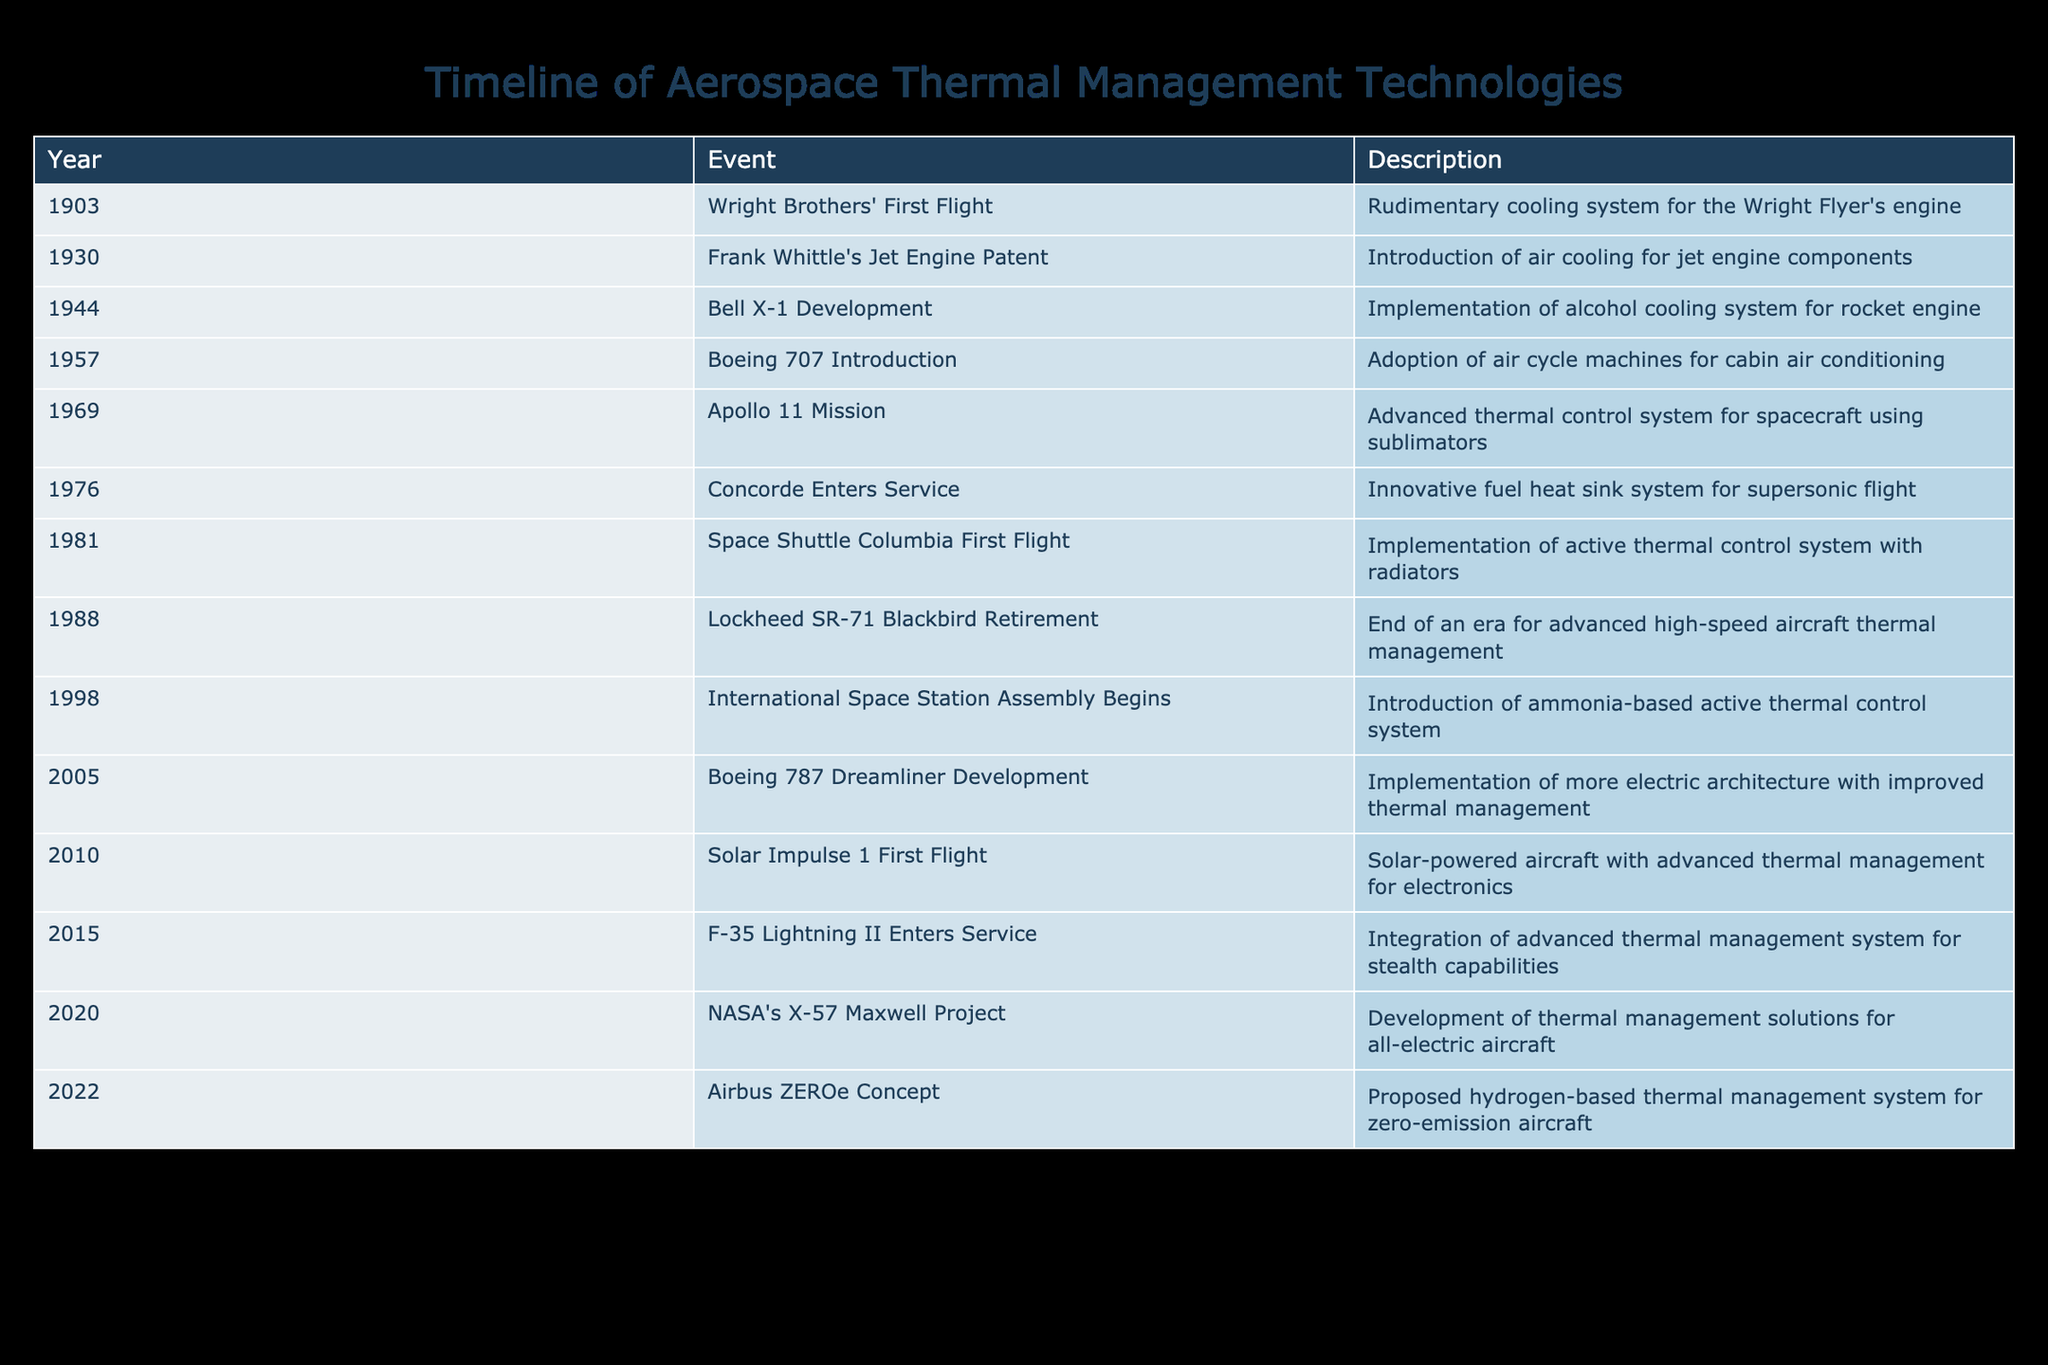What event marks the introduction of air cooling for jet engines? According to the table, the event that marks the introduction of air cooling for jet engines is Frank Whittle's Jet Engine Patent, which occurred in 1930.
Answer: Frank Whittle's Jet Engine Patent How many years passed between the Apollo 11 Mission and the Boeing 787 Dreamliner Development? The Apollo 11 Mission took place in 1969, and the Boeing 787 Dreamliner Development began in 2005. The difference in years is calculated as 2005 - 1969 = 36 years.
Answer: 36 years Is the Bell X-1 Development associated with a cooling system? Yes, the Bell X-1 Development in 1944 is noted for the implementation of an alcohol cooling system for rocket engines.
Answer: Yes What was the last event listed in the table? Reviewing the table, the last event listed is the Airbus ZEROe Concept, proposed in 2022, which discusses a hydrogen-based thermal management system for zero-emission aircraft.
Answer: Airbus ZEROe Concept What was the average number of years between the events listed from 1944 to 2010? The events from 1944 to 2010 in the table include Bell X-1 Development (1944), Space Shuttle Columbia First Flight (1981), and Solar Impulse 1 First Flight (2010). The years are 1944, 1981, and 2010. First, we calculate the intervals: 1981 - 1944 = 37 years, and 2010 - 1981 = 29 years. The total interval is 37 + 29 = 66 years, and there are 2 gaps, so the average is 66 / 2 = 33 years.
Answer: 33 years How many events between 2000 and 2022 involved advanced thermal management systems? Reviewing the table, the events between 2000 and 2022 are: International Space Station Assembly Begins (1998), Boeing 787 Dreamliner Development (2005), F-35 Lightning II Enters Service (2015), NASA's X-57 Maxwell Project (2020), and Airbus ZEROe Concept (2022). Of these events, three specifically mention advancements in thermal management systems: Boeing 787, F-35 Lightning II, and Airbus ZEROe.
Answer: 3 events 